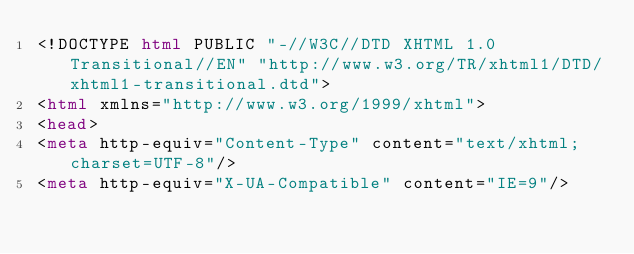Convert code to text. <code><loc_0><loc_0><loc_500><loc_500><_HTML_><!DOCTYPE html PUBLIC "-//W3C//DTD XHTML 1.0 Transitional//EN" "http://www.w3.org/TR/xhtml1/DTD/xhtml1-transitional.dtd">
<html xmlns="http://www.w3.org/1999/xhtml">
<head>
<meta http-equiv="Content-Type" content="text/xhtml;charset=UTF-8"/>
<meta http-equiv="X-UA-Compatible" content="IE=9"/></code> 